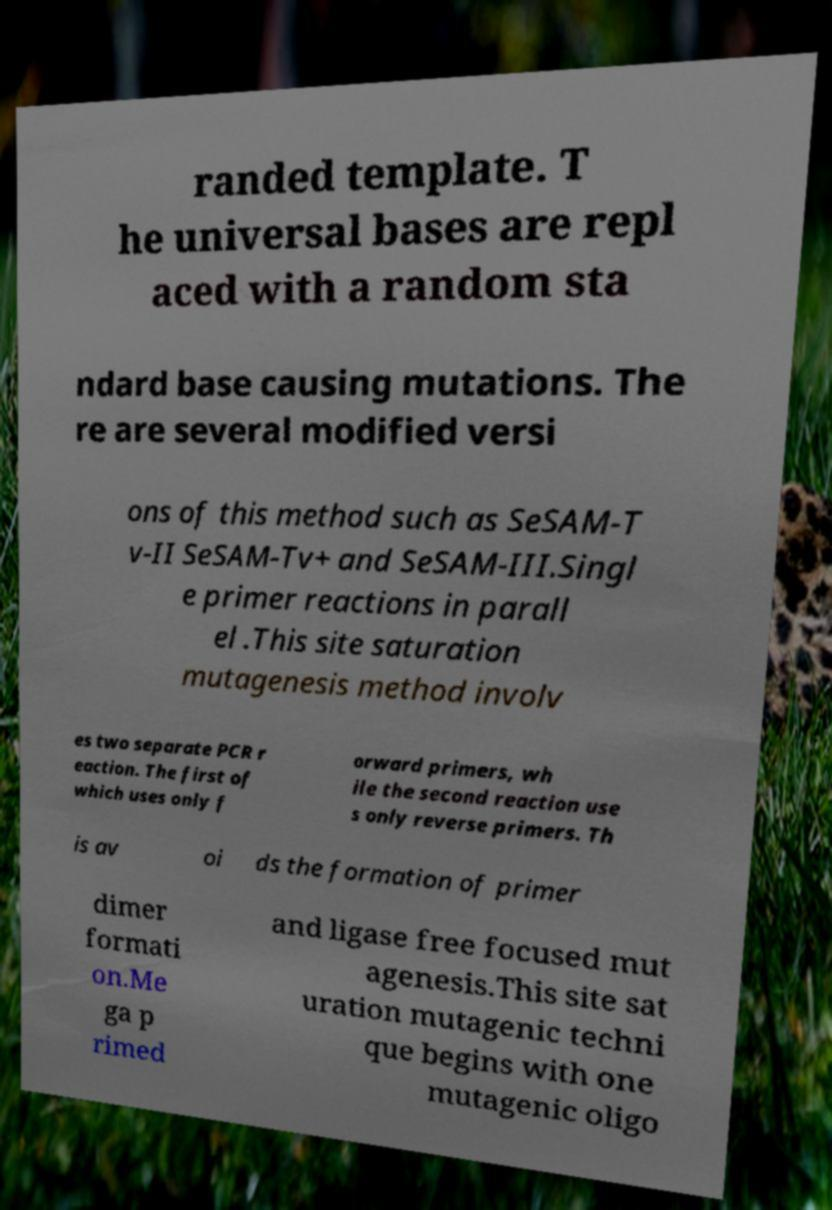Please identify and transcribe the text found in this image. randed template. T he universal bases are repl aced with a random sta ndard base causing mutations. The re are several modified versi ons of this method such as SeSAM-T v-II SeSAM-Tv+ and SeSAM-III.Singl e primer reactions in parall el .This site saturation mutagenesis method involv es two separate PCR r eaction. The first of which uses only f orward primers, wh ile the second reaction use s only reverse primers. Th is av oi ds the formation of primer dimer formati on.Me ga p rimed and ligase free focused mut agenesis.This site sat uration mutagenic techni que begins with one mutagenic oligo 